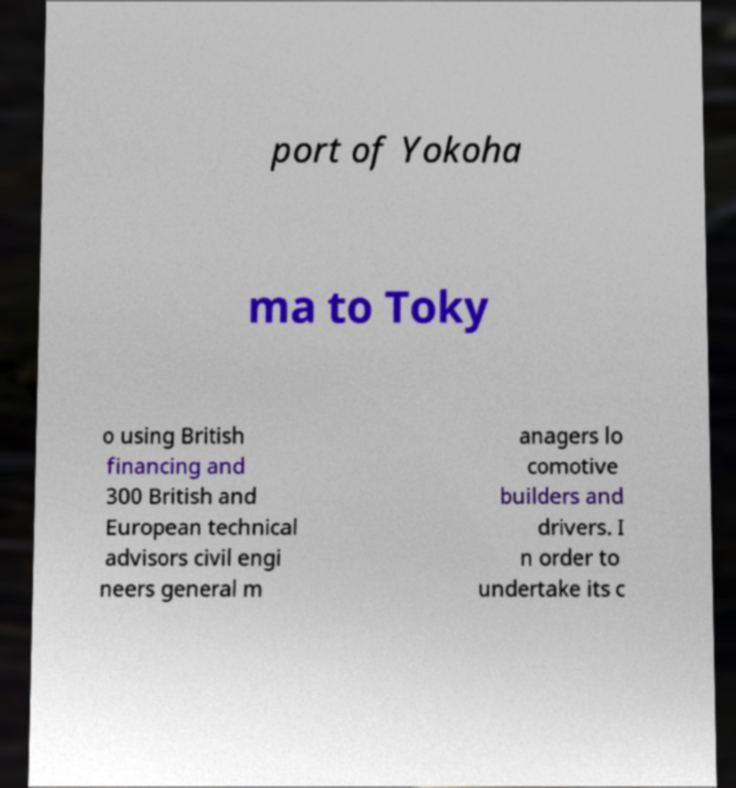There's text embedded in this image that I need extracted. Can you transcribe it verbatim? port of Yokoha ma to Toky o using British financing and 300 British and European technical advisors civil engi neers general m anagers lo comotive builders and drivers. I n order to undertake its c 